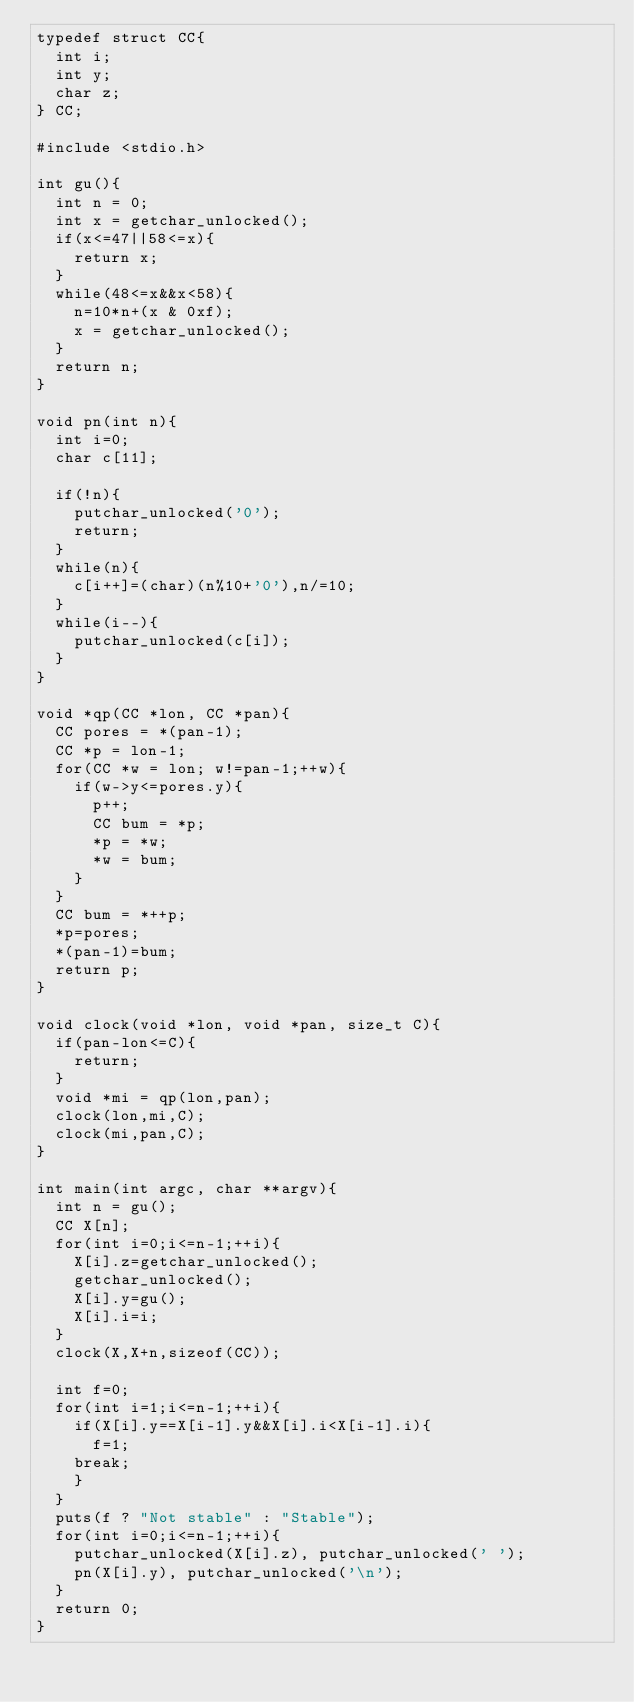<code> <loc_0><loc_0><loc_500><loc_500><_C_>typedef struct CC{
  int i;
  int y;
  char z;
} CC;

#include <stdio.h>

int gu(){
  int n = 0;
  int x = getchar_unlocked();
  if(x<=47||58<=x){
    return x;
  }
  while(48<=x&&x<58){
    n=10*n+(x & 0xf);
    x = getchar_unlocked();
  }
  return n;
}

void pn(int n){
  int i=0;
  char c[11];
  
  if(!n){
    putchar_unlocked('0');
    return;
  }
  while(n){
    c[i++]=(char)(n%10+'0'),n/=10;
  }
  while(i--){
    putchar_unlocked(c[i]);
  }
}

void *qp(CC *lon, CC *pan){
  CC pores = *(pan-1);
  CC *p = lon-1;
  for(CC *w = lon; w!=pan-1;++w){
    if(w->y<=pores.y){
      p++;
      CC bum = *p;
      *p = *w;
      *w = bum;
    }
  }
  CC bum = *++p;
  *p=pores;
  *(pan-1)=bum;
  return p;
}

void clock(void *lon, void *pan, size_t C){
  if(pan-lon<=C){
    return;
  }
  void *mi = qp(lon,pan);
  clock(lon,mi,C);
  clock(mi,pan,C);
}

int main(int argc, char **argv){
  int n = gu();
  CC X[n];
  for(int i=0;i<=n-1;++i){
    X[i].z=getchar_unlocked();
    getchar_unlocked();
    X[i].y=gu();
    X[i].i=i;
  }
  clock(X,X+n,sizeof(CC));

  int f=0;
  for(int i=1;i<=n-1;++i){
    if(X[i].y==X[i-1].y&&X[i].i<X[i-1].i){
      f=1;
	break;
    }
  }
  puts(f ? "Not stable" : "Stable");
  for(int i=0;i<=n-1;++i){
    putchar_unlocked(X[i].z), putchar_unlocked(' ');
    pn(X[i].y), putchar_unlocked('\n');
  }
  return 0;
}

</code> 